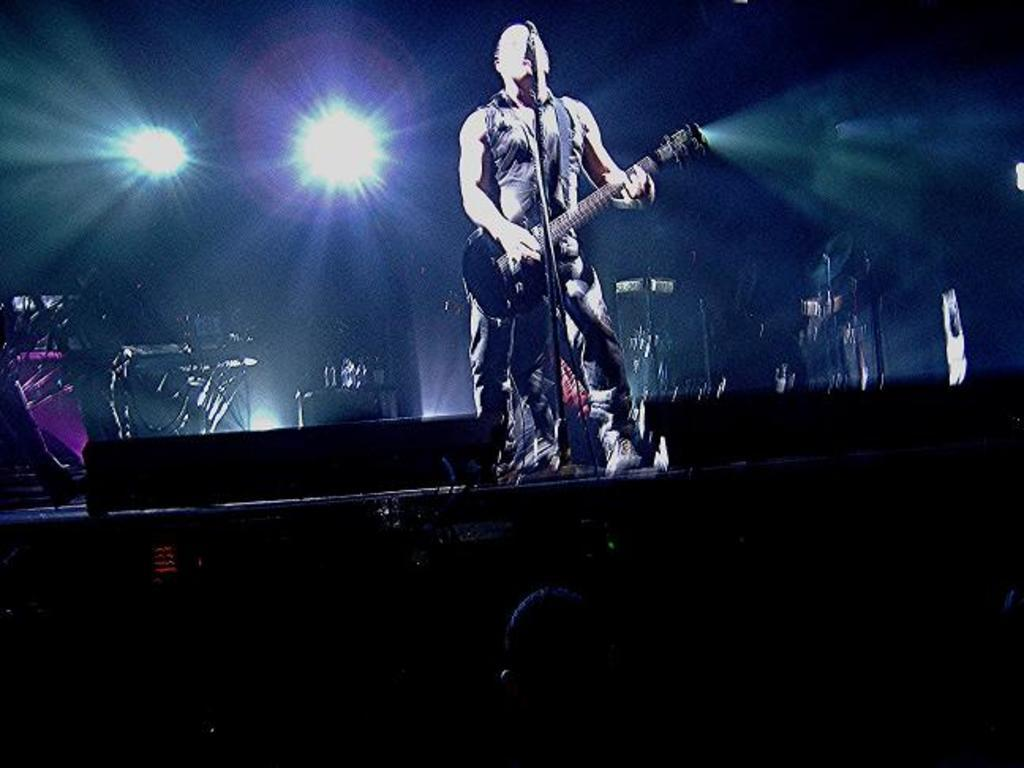Who is the main subject in the image? There is a man in the image. What is the man doing in the image? The man is standing on a stage and playing a guitar. What is the man using to amplify his voice in the image? There is a microphone in front of the man. What else can be seen in the background of the image? Musical instruments and lights are present in the background of the image. What type of mist is covering the stage in the image? There is no mist present in the image; the stage is clear and visible. 